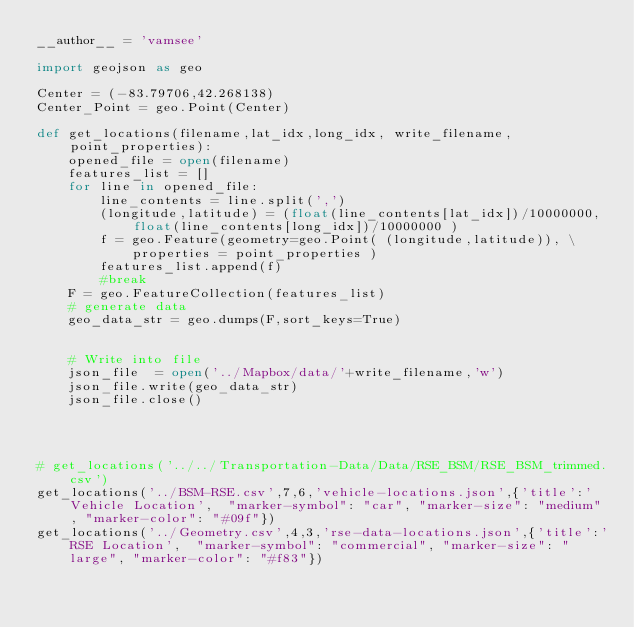Convert code to text. <code><loc_0><loc_0><loc_500><loc_500><_Python_>__author__ = 'vamsee'

import geojson as geo

Center = (-83.79706,42.268138)
Center_Point = geo.Point(Center)

def get_locations(filename,lat_idx,long_idx, write_filename,point_properties):
    opened_file = open(filename)
    features_list = []
    for line in opened_file:
        line_contents = line.split(',')
        (longitude,latitude) = (float(line_contents[lat_idx])/10000000,float(line_contents[long_idx])/10000000 )
        f = geo.Feature(geometry=geo.Point( (longitude,latitude)), \
            properties = point_properties )
        features_list.append(f)
        #break
    F = geo.FeatureCollection(features_list)
    # generate data
    geo_data_str = geo.dumps(F,sort_keys=True)


    # Write into file
    json_file  = open('../Mapbox/data/'+write_filename,'w')
    json_file.write(geo_data_str)
    json_file.close()




# get_locations('../../Transportation-Data/Data/RSE_BSM/RSE_BSM_trimmed.csv')
get_locations('../BSM-RSE.csv',7,6,'vehicle-locations.json',{'title':'Vehicle Location',  "marker-symbol": "car", "marker-size": "medium", "marker-color": "#09f"})
get_locations('../Geometry.csv',4,3,'rse-data-locations.json',{'title':'RSE Location',  "marker-symbol": "commercial", "marker-size": "large", "marker-color": "#f83"})
</code> 